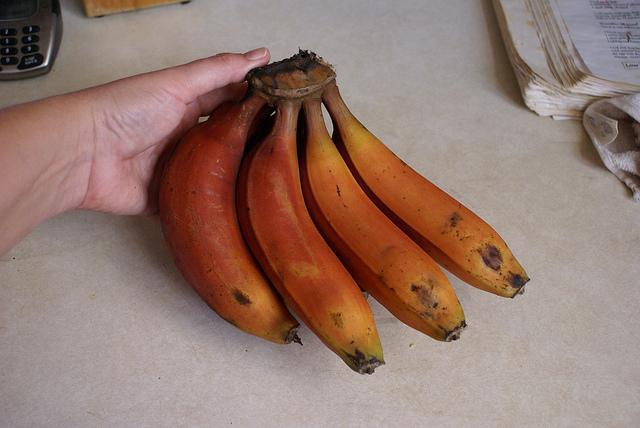Is "The person is surrounding the banana." an appropriate description for the image?
Answer yes or no. No. Is the given caption "The banana is inside the person." fitting for the image?
Answer yes or no. No. 